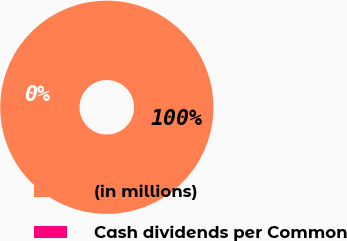<chart> <loc_0><loc_0><loc_500><loc_500><pie_chart><fcel>(in millions)<fcel>Cash dividends per Common<nl><fcel>99.97%<fcel>0.03%<nl></chart> 